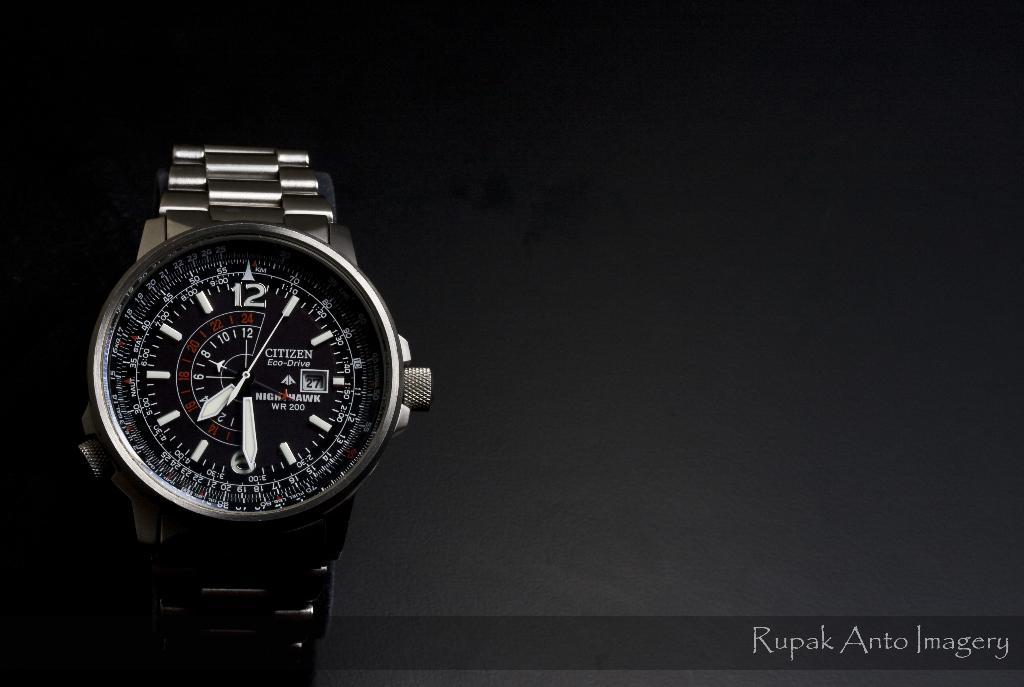<image>
Render a clear and concise summary of the photo. The black Citizen watch shows the multiple functions available. 